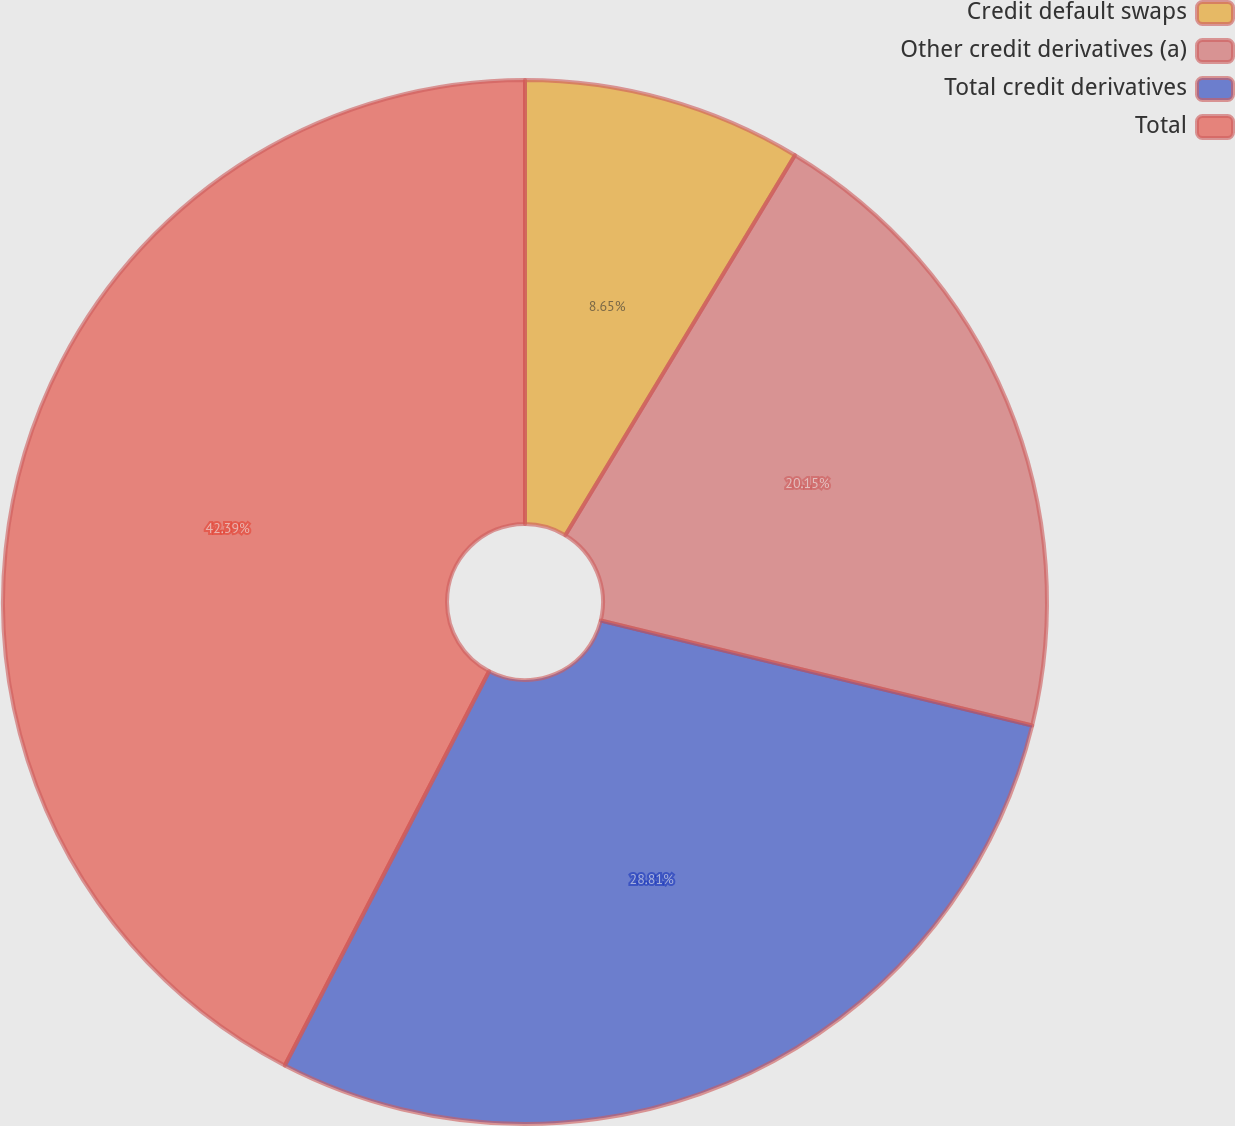<chart> <loc_0><loc_0><loc_500><loc_500><pie_chart><fcel>Credit default swaps<fcel>Other credit derivatives (a)<fcel>Total credit derivatives<fcel>Total<nl><fcel>8.65%<fcel>20.15%<fcel>28.81%<fcel>42.39%<nl></chart> 